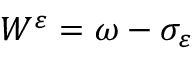<formula> <loc_0><loc_0><loc_500><loc_500>W ^ { \varepsilon } = \omega - \sigma _ { \varepsilon }</formula> 